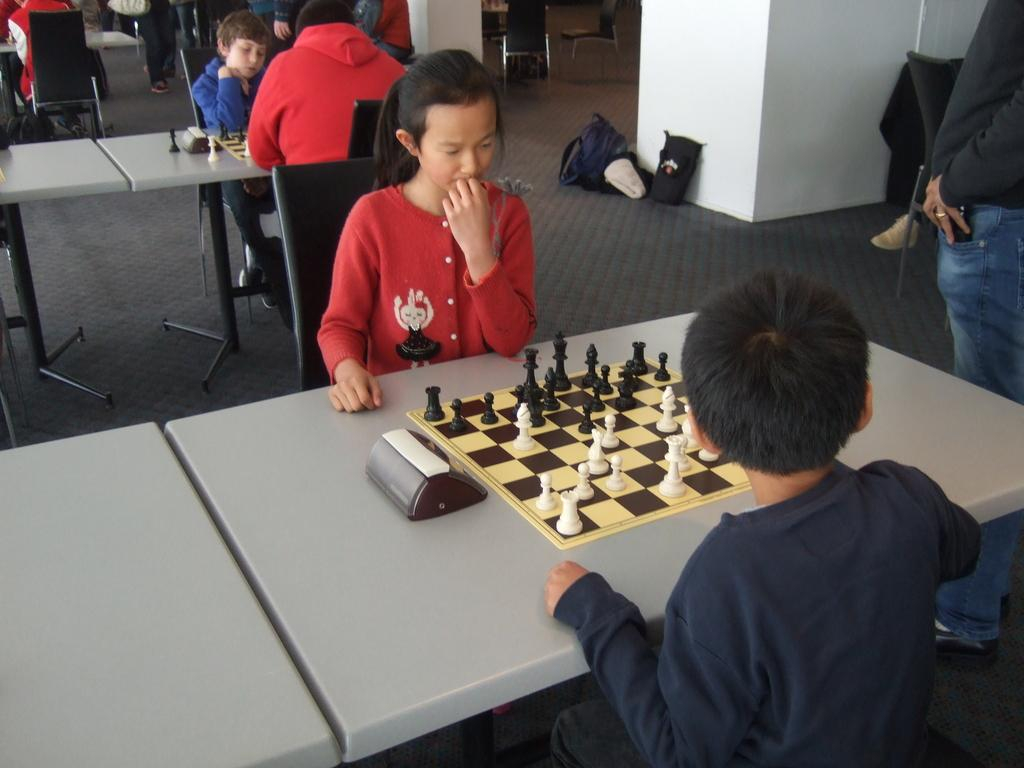What are the people in the image doing? The people are sitting on chairs and playing chess on the tables. Where are the chairs located in relation to the tables? The chairs are near the tables. What can be seen near a wall in the image? There are bags near a wall in the image. How many cars are parked on the chessboard in the image? There are no cars present in the image, as it features people playing chess on tables. 